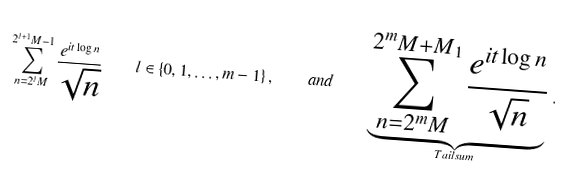<formula> <loc_0><loc_0><loc_500><loc_500>\sum _ { n = 2 ^ { l } M } ^ { 2 ^ { l + 1 } M - 1 } \frac { e ^ { i t \log n } } { \sqrt { n } } \quad l \in \{ 0 , 1 , \dots , m - 1 \} \, , \quad a n d \quad \underbrace { \sum _ { n = 2 ^ { m } M } ^ { 2 ^ { m } M + M _ { 1 } } \frac { e ^ { i t \log n } } { \sqrt { n } } } _ { T a i l s u m } \, .</formula> 